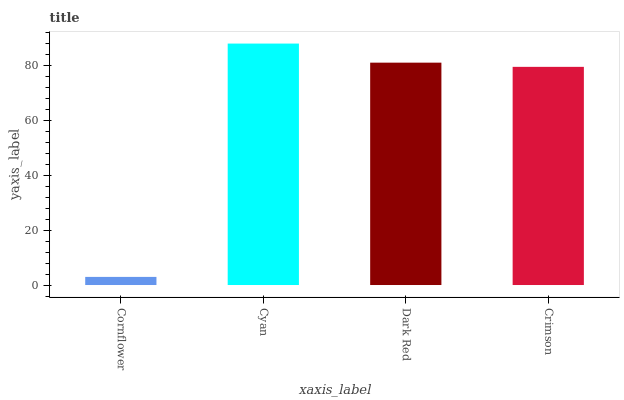Is Cornflower the minimum?
Answer yes or no. Yes. Is Cyan the maximum?
Answer yes or no. Yes. Is Dark Red the minimum?
Answer yes or no. No. Is Dark Red the maximum?
Answer yes or no. No. Is Cyan greater than Dark Red?
Answer yes or no. Yes. Is Dark Red less than Cyan?
Answer yes or no. Yes. Is Dark Red greater than Cyan?
Answer yes or no. No. Is Cyan less than Dark Red?
Answer yes or no. No. Is Dark Red the high median?
Answer yes or no. Yes. Is Crimson the low median?
Answer yes or no. Yes. Is Cyan the high median?
Answer yes or no. No. Is Dark Red the low median?
Answer yes or no. No. 